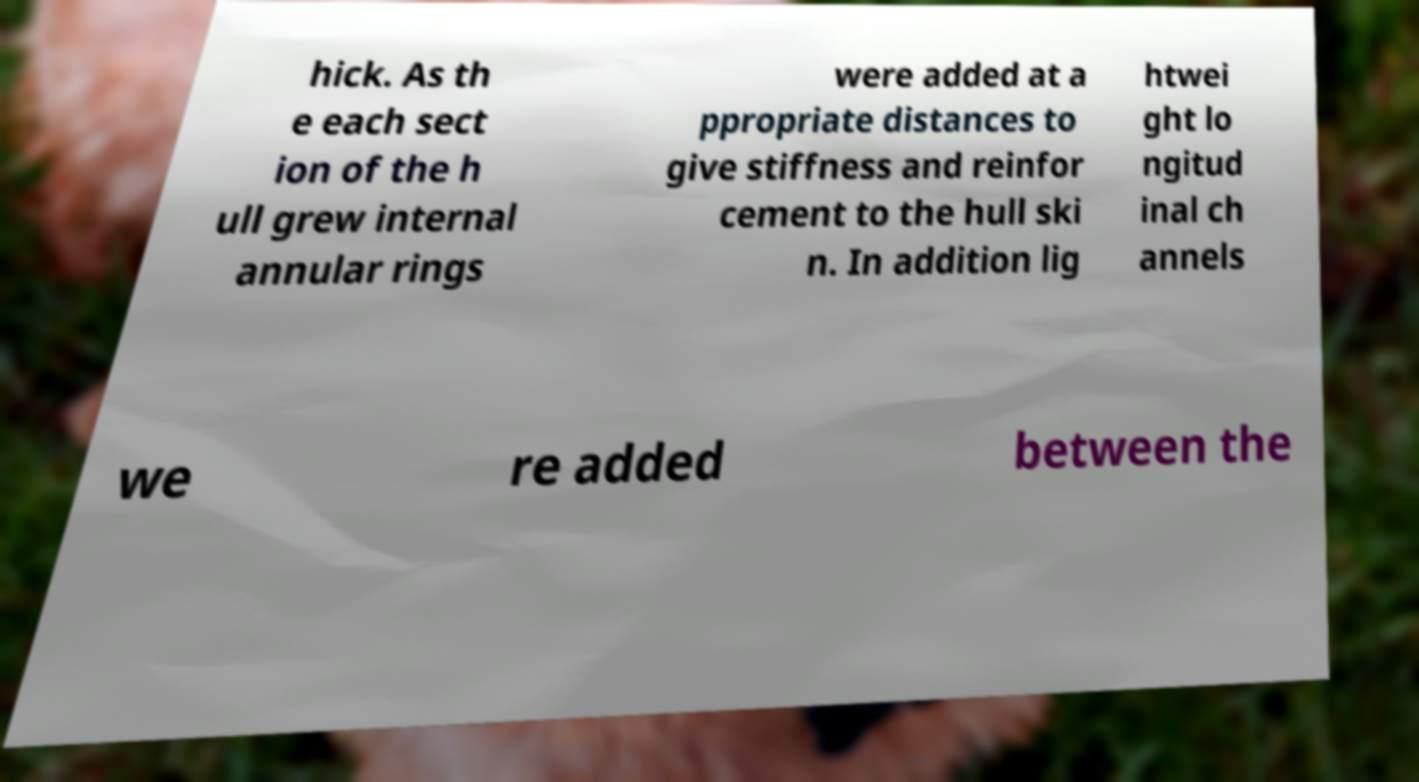Could you extract and type out the text from this image? hick. As th e each sect ion of the h ull grew internal annular rings were added at a ppropriate distances to give stiffness and reinfor cement to the hull ski n. In addition lig htwei ght lo ngitud inal ch annels we re added between the 